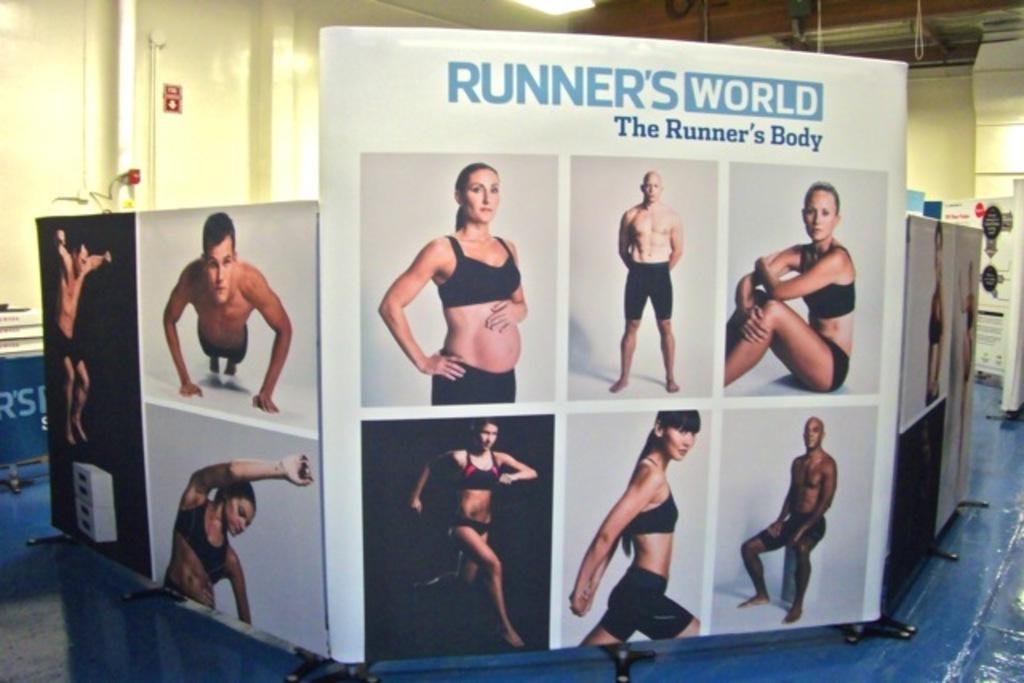Can you describe this image briefly? There are white banners on which there are images of people. There is a wall at the back and a light on the top. 